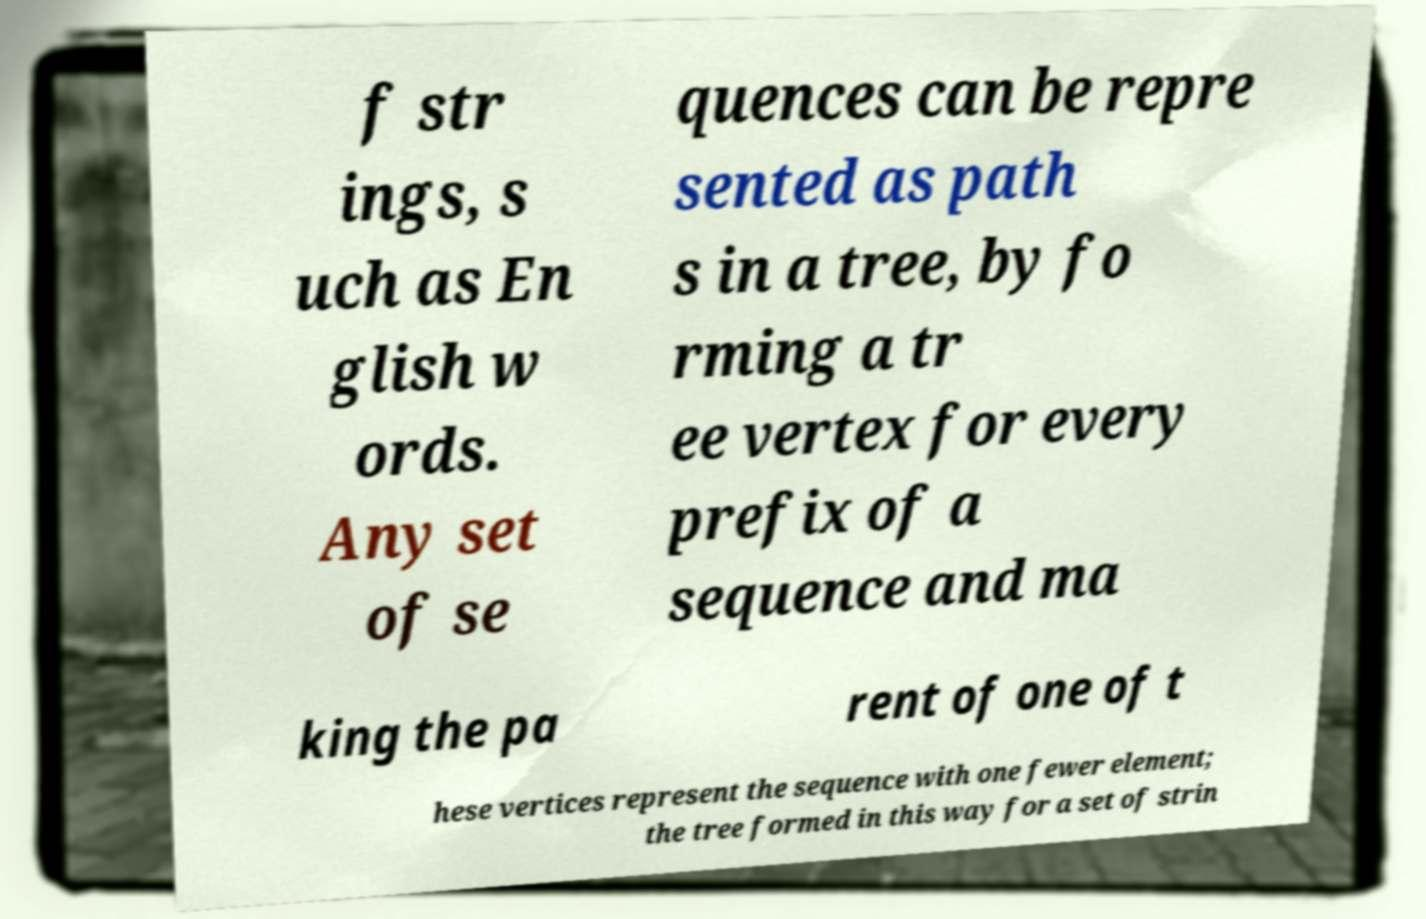What messages or text are displayed in this image? I need them in a readable, typed format. f str ings, s uch as En glish w ords. Any set of se quences can be repre sented as path s in a tree, by fo rming a tr ee vertex for every prefix of a sequence and ma king the pa rent of one of t hese vertices represent the sequence with one fewer element; the tree formed in this way for a set of strin 